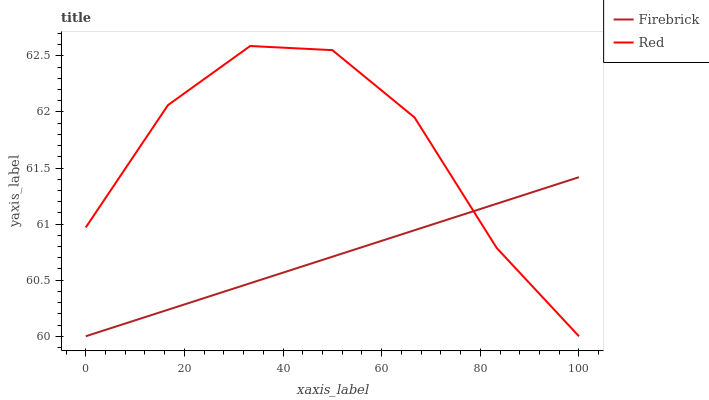Does Firebrick have the minimum area under the curve?
Answer yes or no. Yes. Does Red have the maximum area under the curve?
Answer yes or no. Yes. Does Red have the minimum area under the curve?
Answer yes or no. No. Is Firebrick the smoothest?
Answer yes or no. Yes. Is Red the roughest?
Answer yes or no. Yes. Is Red the smoothest?
Answer yes or no. No. Does Firebrick have the lowest value?
Answer yes or no. Yes. Does Red have the highest value?
Answer yes or no. Yes. Does Firebrick intersect Red?
Answer yes or no. Yes. Is Firebrick less than Red?
Answer yes or no. No. Is Firebrick greater than Red?
Answer yes or no. No. 